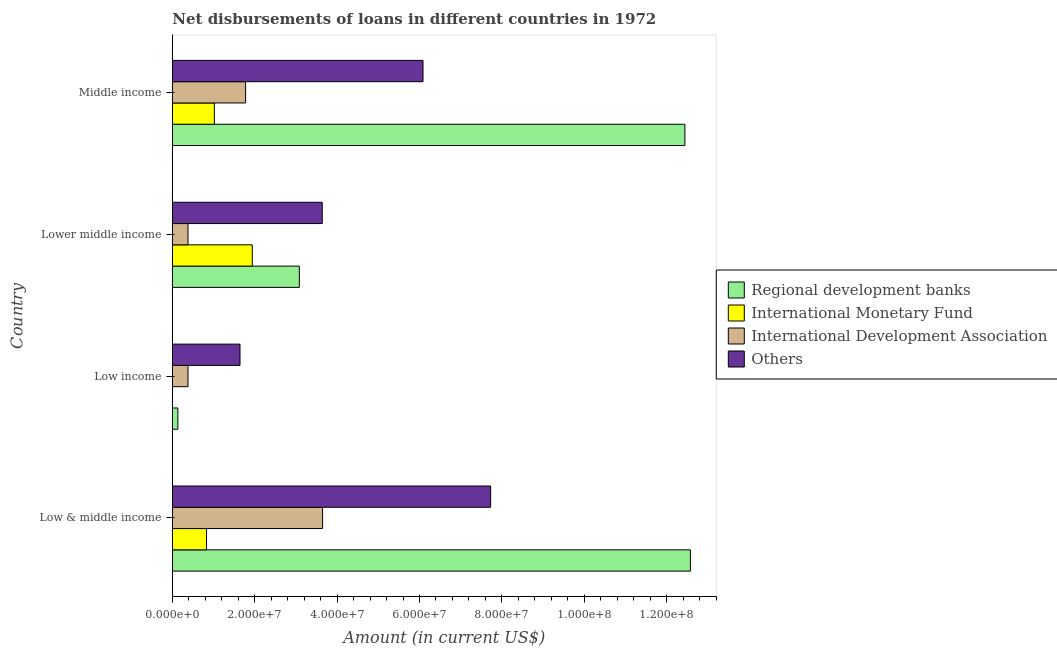How many different coloured bars are there?
Offer a terse response. 4. Are the number of bars on each tick of the Y-axis equal?
Give a very brief answer. No. How many bars are there on the 4th tick from the bottom?
Give a very brief answer. 4. What is the label of the 2nd group of bars from the top?
Your answer should be compact. Lower middle income. What is the amount of loan disimbursed by regional development banks in Low & middle income?
Your response must be concise. 1.26e+08. Across all countries, what is the maximum amount of loan disimbursed by other organisations?
Your response must be concise. 7.73e+07. Across all countries, what is the minimum amount of loan disimbursed by other organisations?
Your answer should be compact. 1.64e+07. What is the total amount of loan disimbursed by regional development banks in the graph?
Your answer should be very brief. 2.82e+08. What is the difference between the amount of loan disimbursed by other organisations in Low & middle income and that in Low income?
Your response must be concise. 6.09e+07. What is the difference between the amount of loan disimbursed by international monetary fund in Low & middle income and the amount of loan disimbursed by regional development banks in Lower middle income?
Give a very brief answer. -2.25e+07. What is the average amount of loan disimbursed by other organisations per country?
Keep it short and to the point. 4.77e+07. What is the difference between the amount of loan disimbursed by international monetary fund and amount of loan disimbursed by regional development banks in Low & middle income?
Your answer should be very brief. -1.17e+08. In how many countries, is the amount of loan disimbursed by international monetary fund greater than 12000000 US$?
Give a very brief answer. 1. What is the difference between the highest and the second highest amount of loan disimbursed by other organisations?
Provide a succinct answer. 1.64e+07. What is the difference between the highest and the lowest amount of loan disimbursed by international development association?
Provide a short and direct response. 3.27e+07. In how many countries, is the amount of loan disimbursed by regional development banks greater than the average amount of loan disimbursed by regional development banks taken over all countries?
Your response must be concise. 2. Is it the case that in every country, the sum of the amount of loan disimbursed by regional development banks and amount of loan disimbursed by international monetary fund is greater than the amount of loan disimbursed by international development association?
Your answer should be very brief. No. Are all the bars in the graph horizontal?
Your response must be concise. Yes. What is the difference between two consecutive major ticks on the X-axis?
Give a very brief answer. 2.00e+07. Does the graph contain any zero values?
Offer a very short reply. Yes. Does the graph contain grids?
Provide a short and direct response. No. How are the legend labels stacked?
Your answer should be very brief. Vertical. What is the title of the graph?
Your answer should be compact. Net disbursements of loans in different countries in 1972. Does "Social Insurance" appear as one of the legend labels in the graph?
Your answer should be very brief. No. What is the label or title of the Y-axis?
Provide a succinct answer. Country. What is the Amount (in current US$) of Regional development banks in Low & middle income?
Provide a short and direct response. 1.26e+08. What is the Amount (in current US$) in International Monetary Fund in Low & middle income?
Your answer should be compact. 8.30e+06. What is the Amount (in current US$) of International Development Association in Low & middle income?
Offer a very short reply. 3.65e+07. What is the Amount (in current US$) in Others in Low & middle income?
Offer a terse response. 7.73e+07. What is the Amount (in current US$) of Regional development banks in Low income?
Your response must be concise. 1.33e+06. What is the Amount (in current US$) in International Development Association in Low income?
Your answer should be compact. 3.80e+06. What is the Amount (in current US$) in Others in Low income?
Offer a very short reply. 1.64e+07. What is the Amount (in current US$) in Regional development banks in Lower middle income?
Your response must be concise. 3.08e+07. What is the Amount (in current US$) in International Monetary Fund in Lower middle income?
Make the answer very short. 1.94e+07. What is the Amount (in current US$) of International Development Association in Lower middle income?
Ensure brevity in your answer.  3.80e+06. What is the Amount (in current US$) in Others in Lower middle income?
Your response must be concise. 3.64e+07. What is the Amount (in current US$) of Regional development banks in Middle income?
Provide a succinct answer. 1.24e+08. What is the Amount (in current US$) of International Monetary Fund in Middle income?
Keep it short and to the point. 1.02e+07. What is the Amount (in current US$) of International Development Association in Middle income?
Provide a short and direct response. 1.78e+07. What is the Amount (in current US$) of Others in Middle income?
Ensure brevity in your answer.  6.09e+07. Across all countries, what is the maximum Amount (in current US$) of Regional development banks?
Provide a short and direct response. 1.26e+08. Across all countries, what is the maximum Amount (in current US$) in International Monetary Fund?
Make the answer very short. 1.94e+07. Across all countries, what is the maximum Amount (in current US$) in International Development Association?
Offer a very short reply. 3.65e+07. Across all countries, what is the maximum Amount (in current US$) of Others?
Your answer should be very brief. 7.73e+07. Across all countries, what is the minimum Amount (in current US$) in Regional development banks?
Your response must be concise. 1.33e+06. Across all countries, what is the minimum Amount (in current US$) in International Development Association?
Offer a very short reply. 3.80e+06. Across all countries, what is the minimum Amount (in current US$) of Others?
Make the answer very short. 1.64e+07. What is the total Amount (in current US$) of Regional development banks in the graph?
Your response must be concise. 2.82e+08. What is the total Amount (in current US$) of International Monetary Fund in the graph?
Your answer should be compact. 3.79e+07. What is the total Amount (in current US$) in International Development Association in the graph?
Provide a succinct answer. 6.18e+07. What is the total Amount (in current US$) in Others in the graph?
Your answer should be compact. 1.91e+08. What is the difference between the Amount (in current US$) of Regional development banks in Low & middle income and that in Low income?
Your answer should be compact. 1.24e+08. What is the difference between the Amount (in current US$) of International Development Association in Low & middle income and that in Low income?
Give a very brief answer. 3.27e+07. What is the difference between the Amount (in current US$) in Others in Low & middle income and that in Low income?
Provide a succinct answer. 6.09e+07. What is the difference between the Amount (in current US$) in Regional development banks in Low & middle income and that in Lower middle income?
Make the answer very short. 9.49e+07. What is the difference between the Amount (in current US$) in International Monetary Fund in Low & middle income and that in Lower middle income?
Keep it short and to the point. -1.11e+07. What is the difference between the Amount (in current US$) in International Development Association in Low & middle income and that in Lower middle income?
Provide a short and direct response. 3.27e+07. What is the difference between the Amount (in current US$) in Others in Low & middle income and that in Lower middle income?
Provide a succinct answer. 4.09e+07. What is the difference between the Amount (in current US$) of Regional development banks in Low & middle income and that in Middle income?
Provide a short and direct response. 1.33e+06. What is the difference between the Amount (in current US$) of International Monetary Fund in Low & middle income and that in Middle income?
Keep it short and to the point. -1.90e+06. What is the difference between the Amount (in current US$) of International Development Association in Low & middle income and that in Middle income?
Your answer should be very brief. 1.87e+07. What is the difference between the Amount (in current US$) in Others in Low & middle income and that in Middle income?
Your answer should be very brief. 1.64e+07. What is the difference between the Amount (in current US$) of Regional development banks in Low income and that in Lower middle income?
Provide a succinct answer. -2.95e+07. What is the difference between the Amount (in current US$) of Others in Low income and that in Lower middle income?
Provide a succinct answer. -2.00e+07. What is the difference between the Amount (in current US$) in Regional development banks in Low income and that in Middle income?
Provide a succinct answer. -1.23e+08. What is the difference between the Amount (in current US$) of International Development Association in Low income and that in Middle income?
Your answer should be very brief. -1.40e+07. What is the difference between the Amount (in current US$) of Others in Low income and that in Middle income?
Your answer should be very brief. -4.44e+07. What is the difference between the Amount (in current US$) in Regional development banks in Lower middle income and that in Middle income?
Your response must be concise. -9.36e+07. What is the difference between the Amount (in current US$) of International Monetary Fund in Lower middle income and that in Middle income?
Your answer should be compact. 9.21e+06. What is the difference between the Amount (in current US$) in International Development Association in Lower middle income and that in Middle income?
Ensure brevity in your answer.  -1.40e+07. What is the difference between the Amount (in current US$) of Others in Lower middle income and that in Middle income?
Offer a very short reply. -2.45e+07. What is the difference between the Amount (in current US$) of Regional development banks in Low & middle income and the Amount (in current US$) of International Development Association in Low income?
Offer a terse response. 1.22e+08. What is the difference between the Amount (in current US$) of Regional development banks in Low & middle income and the Amount (in current US$) of Others in Low income?
Make the answer very short. 1.09e+08. What is the difference between the Amount (in current US$) in International Monetary Fund in Low & middle income and the Amount (in current US$) in International Development Association in Low income?
Your response must be concise. 4.50e+06. What is the difference between the Amount (in current US$) in International Monetary Fund in Low & middle income and the Amount (in current US$) in Others in Low income?
Provide a succinct answer. -8.12e+06. What is the difference between the Amount (in current US$) of International Development Association in Low & middle income and the Amount (in current US$) of Others in Low income?
Provide a succinct answer. 2.00e+07. What is the difference between the Amount (in current US$) in Regional development banks in Low & middle income and the Amount (in current US$) in International Monetary Fund in Lower middle income?
Your answer should be very brief. 1.06e+08. What is the difference between the Amount (in current US$) of Regional development banks in Low & middle income and the Amount (in current US$) of International Development Association in Lower middle income?
Ensure brevity in your answer.  1.22e+08. What is the difference between the Amount (in current US$) of Regional development banks in Low & middle income and the Amount (in current US$) of Others in Lower middle income?
Offer a very short reply. 8.94e+07. What is the difference between the Amount (in current US$) in International Monetary Fund in Low & middle income and the Amount (in current US$) in International Development Association in Lower middle income?
Provide a short and direct response. 4.50e+06. What is the difference between the Amount (in current US$) of International Monetary Fund in Low & middle income and the Amount (in current US$) of Others in Lower middle income?
Offer a terse response. -2.81e+07. What is the difference between the Amount (in current US$) in International Development Association in Low & middle income and the Amount (in current US$) in Others in Lower middle income?
Your answer should be compact. 8.30e+04. What is the difference between the Amount (in current US$) in Regional development banks in Low & middle income and the Amount (in current US$) in International Monetary Fund in Middle income?
Your answer should be compact. 1.16e+08. What is the difference between the Amount (in current US$) in Regional development banks in Low & middle income and the Amount (in current US$) in International Development Association in Middle income?
Your answer should be compact. 1.08e+08. What is the difference between the Amount (in current US$) of Regional development banks in Low & middle income and the Amount (in current US$) of Others in Middle income?
Provide a succinct answer. 6.49e+07. What is the difference between the Amount (in current US$) in International Monetary Fund in Low & middle income and the Amount (in current US$) in International Development Association in Middle income?
Your answer should be very brief. -9.48e+06. What is the difference between the Amount (in current US$) of International Monetary Fund in Low & middle income and the Amount (in current US$) of Others in Middle income?
Make the answer very short. -5.26e+07. What is the difference between the Amount (in current US$) in International Development Association in Low & middle income and the Amount (in current US$) in Others in Middle income?
Offer a terse response. -2.44e+07. What is the difference between the Amount (in current US$) in Regional development banks in Low income and the Amount (in current US$) in International Monetary Fund in Lower middle income?
Your answer should be compact. -1.81e+07. What is the difference between the Amount (in current US$) in Regional development banks in Low income and the Amount (in current US$) in International Development Association in Lower middle income?
Offer a terse response. -2.46e+06. What is the difference between the Amount (in current US$) of Regional development banks in Low income and the Amount (in current US$) of Others in Lower middle income?
Make the answer very short. -3.51e+07. What is the difference between the Amount (in current US$) of International Development Association in Low income and the Amount (in current US$) of Others in Lower middle income?
Your answer should be compact. -3.26e+07. What is the difference between the Amount (in current US$) of Regional development banks in Low income and the Amount (in current US$) of International Monetary Fund in Middle income?
Provide a short and direct response. -8.86e+06. What is the difference between the Amount (in current US$) in Regional development banks in Low income and the Amount (in current US$) in International Development Association in Middle income?
Keep it short and to the point. -1.64e+07. What is the difference between the Amount (in current US$) in Regional development banks in Low income and the Amount (in current US$) in Others in Middle income?
Your response must be concise. -5.95e+07. What is the difference between the Amount (in current US$) of International Development Association in Low income and the Amount (in current US$) of Others in Middle income?
Provide a succinct answer. -5.71e+07. What is the difference between the Amount (in current US$) of Regional development banks in Lower middle income and the Amount (in current US$) of International Monetary Fund in Middle income?
Give a very brief answer. 2.06e+07. What is the difference between the Amount (in current US$) of Regional development banks in Lower middle income and the Amount (in current US$) of International Development Association in Middle income?
Provide a succinct answer. 1.30e+07. What is the difference between the Amount (in current US$) in Regional development banks in Lower middle income and the Amount (in current US$) in Others in Middle income?
Ensure brevity in your answer.  -3.00e+07. What is the difference between the Amount (in current US$) of International Monetary Fund in Lower middle income and the Amount (in current US$) of International Development Association in Middle income?
Offer a very short reply. 1.63e+06. What is the difference between the Amount (in current US$) in International Monetary Fund in Lower middle income and the Amount (in current US$) in Others in Middle income?
Your answer should be compact. -4.14e+07. What is the difference between the Amount (in current US$) of International Development Association in Lower middle income and the Amount (in current US$) of Others in Middle income?
Your response must be concise. -5.71e+07. What is the average Amount (in current US$) of Regional development banks per country?
Offer a very short reply. 7.06e+07. What is the average Amount (in current US$) in International Monetary Fund per country?
Provide a succinct answer. 9.47e+06. What is the average Amount (in current US$) in International Development Association per country?
Your answer should be compact. 1.55e+07. What is the average Amount (in current US$) in Others per country?
Your answer should be very brief. 4.77e+07. What is the difference between the Amount (in current US$) in Regional development banks and Amount (in current US$) in International Monetary Fund in Low & middle income?
Keep it short and to the point. 1.17e+08. What is the difference between the Amount (in current US$) in Regional development banks and Amount (in current US$) in International Development Association in Low & middle income?
Ensure brevity in your answer.  8.93e+07. What is the difference between the Amount (in current US$) of Regional development banks and Amount (in current US$) of Others in Low & middle income?
Offer a terse response. 4.85e+07. What is the difference between the Amount (in current US$) in International Monetary Fund and Amount (in current US$) in International Development Association in Low & middle income?
Give a very brief answer. -2.82e+07. What is the difference between the Amount (in current US$) in International Monetary Fund and Amount (in current US$) in Others in Low & middle income?
Your response must be concise. -6.90e+07. What is the difference between the Amount (in current US$) in International Development Association and Amount (in current US$) in Others in Low & middle income?
Give a very brief answer. -4.08e+07. What is the difference between the Amount (in current US$) in Regional development banks and Amount (in current US$) in International Development Association in Low income?
Offer a very short reply. -2.46e+06. What is the difference between the Amount (in current US$) in Regional development banks and Amount (in current US$) in Others in Low income?
Provide a succinct answer. -1.51e+07. What is the difference between the Amount (in current US$) in International Development Association and Amount (in current US$) in Others in Low income?
Your response must be concise. -1.26e+07. What is the difference between the Amount (in current US$) in Regional development banks and Amount (in current US$) in International Monetary Fund in Lower middle income?
Provide a short and direct response. 1.14e+07. What is the difference between the Amount (in current US$) in Regional development banks and Amount (in current US$) in International Development Association in Lower middle income?
Your answer should be very brief. 2.70e+07. What is the difference between the Amount (in current US$) of Regional development banks and Amount (in current US$) of Others in Lower middle income?
Make the answer very short. -5.56e+06. What is the difference between the Amount (in current US$) in International Monetary Fund and Amount (in current US$) in International Development Association in Lower middle income?
Ensure brevity in your answer.  1.56e+07. What is the difference between the Amount (in current US$) of International Monetary Fund and Amount (in current US$) of Others in Lower middle income?
Keep it short and to the point. -1.70e+07. What is the difference between the Amount (in current US$) of International Development Association and Amount (in current US$) of Others in Lower middle income?
Offer a very short reply. -3.26e+07. What is the difference between the Amount (in current US$) of Regional development banks and Amount (in current US$) of International Monetary Fund in Middle income?
Give a very brief answer. 1.14e+08. What is the difference between the Amount (in current US$) of Regional development banks and Amount (in current US$) of International Development Association in Middle income?
Give a very brief answer. 1.07e+08. What is the difference between the Amount (in current US$) of Regional development banks and Amount (in current US$) of Others in Middle income?
Provide a succinct answer. 6.36e+07. What is the difference between the Amount (in current US$) in International Monetary Fund and Amount (in current US$) in International Development Association in Middle income?
Keep it short and to the point. -7.58e+06. What is the difference between the Amount (in current US$) of International Monetary Fund and Amount (in current US$) of Others in Middle income?
Make the answer very short. -5.07e+07. What is the difference between the Amount (in current US$) in International Development Association and Amount (in current US$) in Others in Middle income?
Your response must be concise. -4.31e+07. What is the ratio of the Amount (in current US$) of Regional development banks in Low & middle income to that in Low income?
Give a very brief answer. 94.35. What is the ratio of the Amount (in current US$) in International Development Association in Low & middle income to that in Low income?
Provide a short and direct response. 9.61. What is the ratio of the Amount (in current US$) of Others in Low & middle income to that in Low income?
Give a very brief answer. 4.71. What is the ratio of the Amount (in current US$) in Regional development banks in Low & middle income to that in Lower middle income?
Make the answer very short. 4.08. What is the ratio of the Amount (in current US$) of International Monetary Fund in Low & middle income to that in Lower middle income?
Keep it short and to the point. 0.43. What is the ratio of the Amount (in current US$) in International Development Association in Low & middle income to that in Lower middle income?
Offer a terse response. 9.61. What is the ratio of the Amount (in current US$) in Others in Low & middle income to that in Lower middle income?
Your answer should be very brief. 2.12. What is the ratio of the Amount (in current US$) in Regional development banks in Low & middle income to that in Middle income?
Ensure brevity in your answer.  1.01. What is the ratio of the Amount (in current US$) of International Monetary Fund in Low & middle income to that in Middle income?
Your answer should be very brief. 0.81. What is the ratio of the Amount (in current US$) in International Development Association in Low & middle income to that in Middle income?
Ensure brevity in your answer.  2.05. What is the ratio of the Amount (in current US$) of Others in Low & middle income to that in Middle income?
Your response must be concise. 1.27. What is the ratio of the Amount (in current US$) in Regional development banks in Low income to that in Lower middle income?
Provide a short and direct response. 0.04. What is the ratio of the Amount (in current US$) in Others in Low income to that in Lower middle income?
Your answer should be very brief. 0.45. What is the ratio of the Amount (in current US$) in Regional development banks in Low income to that in Middle income?
Your answer should be compact. 0.01. What is the ratio of the Amount (in current US$) in International Development Association in Low income to that in Middle income?
Your answer should be very brief. 0.21. What is the ratio of the Amount (in current US$) of Others in Low income to that in Middle income?
Ensure brevity in your answer.  0.27. What is the ratio of the Amount (in current US$) of Regional development banks in Lower middle income to that in Middle income?
Offer a terse response. 0.25. What is the ratio of the Amount (in current US$) in International Monetary Fund in Lower middle income to that in Middle income?
Offer a terse response. 1.9. What is the ratio of the Amount (in current US$) of International Development Association in Lower middle income to that in Middle income?
Provide a succinct answer. 0.21. What is the ratio of the Amount (in current US$) in Others in Lower middle income to that in Middle income?
Make the answer very short. 0.6. What is the difference between the highest and the second highest Amount (in current US$) of Regional development banks?
Offer a very short reply. 1.33e+06. What is the difference between the highest and the second highest Amount (in current US$) of International Monetary Fund?
Your answer should be compact. 9.21e+06. What is the difference between the highest and the second highest Amount (in current US$) of International Development Association?
Offer a terse response. 1.87e+07. What is the difference between the highest and the second highest Amount (in current US$) in Others?
Your answer should be very brief. 1.64e+07. What is the difference between the highest and the lowest Amount (in current US$) in Regional development banks?
Provide a short and direct response. 1.24e+08. What is the difference between the highest and the lowest Amount (in current US$) of International Monetary Fund?
Give a very brief answer. 1.94e+07. What is the difference between the highest and the lowest Amount (in current US$) in International Development Association?
Provide a succinct answer. 3.27e+07. What is the difference between the highest and the lowest Amount (in current US$) of Others?
Ensure brevity in your answer.  6.09e+07. 